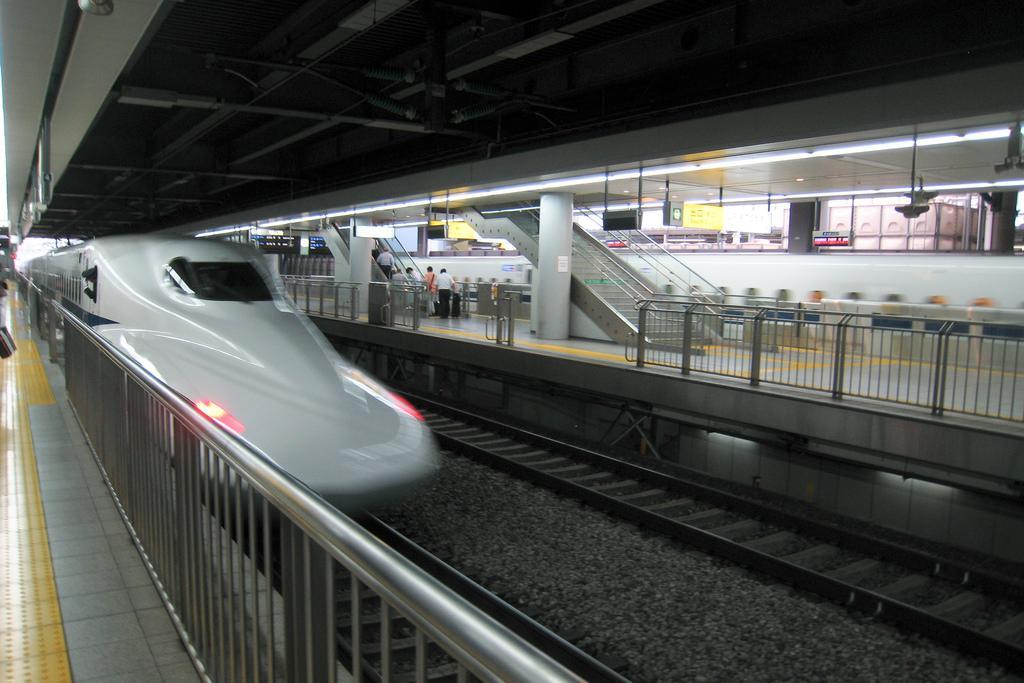Can you describe this image briefly? In this image we can see a metro train is moving on the railway track. Here we can see the platform, steel railing, boards, people moving on the escalator, staircase and the lights in the background. 